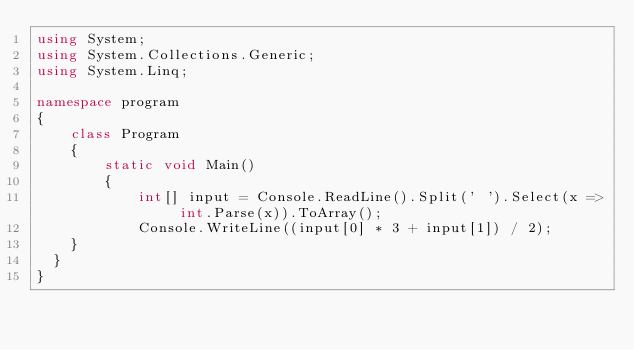Convert code to text. <code><loc_0><loc_0><loc_500><loc_500><_C#_>using System;
using System.Collections.Generic;
using System.Linq;

namespace program
{
    class Program
    {
        static void Main()
        {
            int[] input = Console.ReadLine().Split(' ').Select(x => int.Parse(x)).ToArray();
            Console.WriteLine((input[0] * 3 + input[1]) / 2);
		}
	}
}</code> 